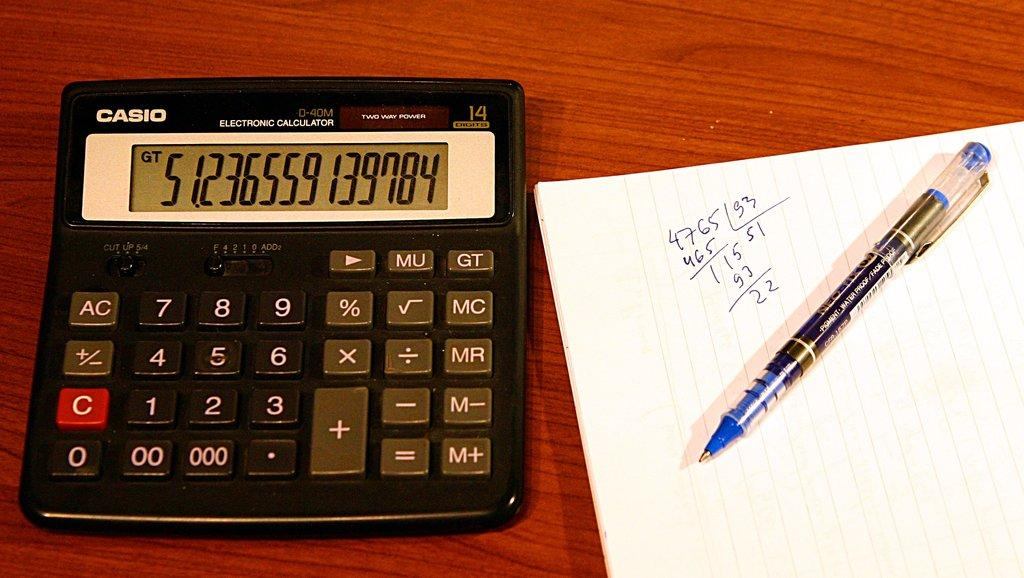<image>
Offer a succinct explanation of the picture presented. A black casio calculator with a notebook page with a blue pen on top of it. 